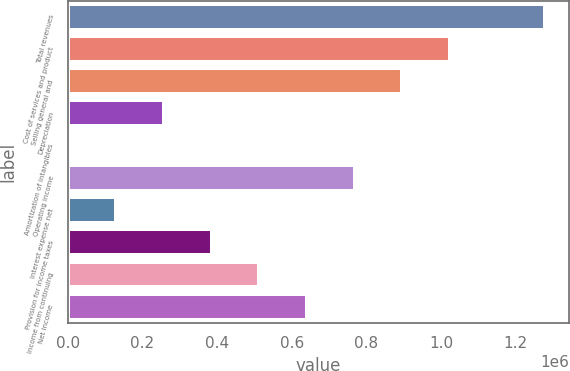<chart> <loc_0><loc_0><loc_500><loc_500><bar_chart><fcel>Total revenues<fcel>Cost of services and product<fcel>Selling general and<fcel>Depreciation<fcel>Amortization of intangibles<fcel>Operating income<fcel>Interest expense net<fcel>Provision for income taxes<fcel>Income from continuing<fcel>Net income<nl><fcel>1.27906e+06<fcel>1.02358e+06<fcel>895830<fcel>257105<fcel>1615<fcel>768085<fcel>129360<fcel>384850<fcel>512595<fcel>640340<nl></chart> 